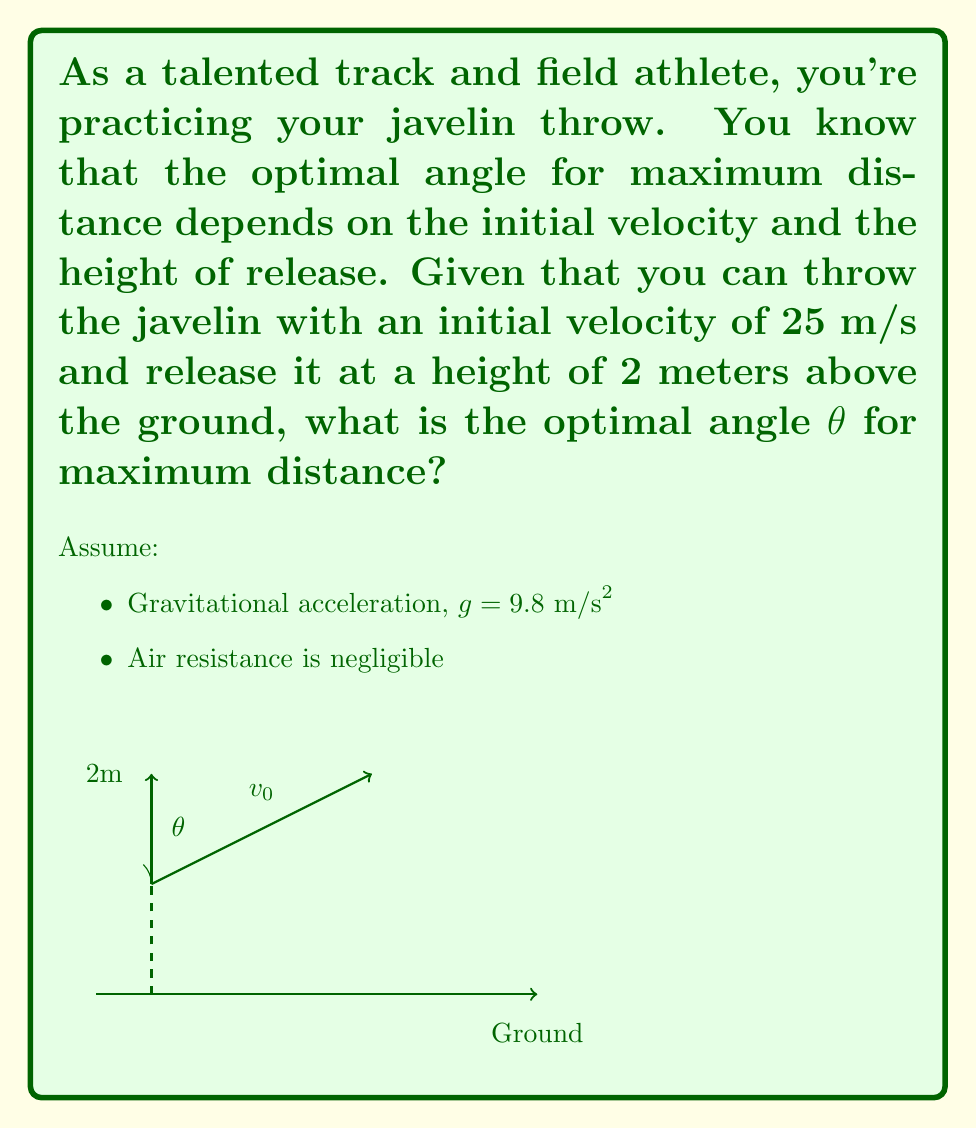Help me with this question. Let's approach this step-by-step:

1) The range (R) of a projectile launched from height h with initial velocity v₀ at an angle θ is given by:

   $$R = \frac{v_0 \cos\theta}{g} \left(v_0 \sin\theta + \sqrt{v_0^2 \sin^2\theta + 2gh}\right)$$

2) To find the optimal angle, we need to maximize this equation. In general, for a flat surface (h = 0), the optimal angle is 45°. However, with a non-zero launch height, the optimal angle is slightly less than 45°.

3) We can find the optimal angle by differentiating R with respect to θ and setting it to zero. However, this leads to a complex equation. Instead, we can use an approximation formula:

   $$\theta_{opt} \approx 45° - \frac{1}{2} \arctan\left(\frac{3gh}{v_0^2}\right)$$

4) Let's plug in our values:
   v₀ = 25 m/s
   g = 9.8 m/s²
   h = 2 m

5) Calculate:
   $$\theta_{opt} \approx 45° - \frac{1}{2} \arctan\left(\frac{3 * 9.8 * 2}{25^2}\right)$$

6) Simplify:
   $$\theta_{opt} \approx 45° - \frac{1}{2} \arctan(0.0941)$$

7) Calculate:
   $$\theta_{opt} \approx 45° - 1.35° = 43.65°$$

Therefore, the optimal angle for the javelin throw under these conditions is approximately 43.65°.
Answer: $43.65°$ 